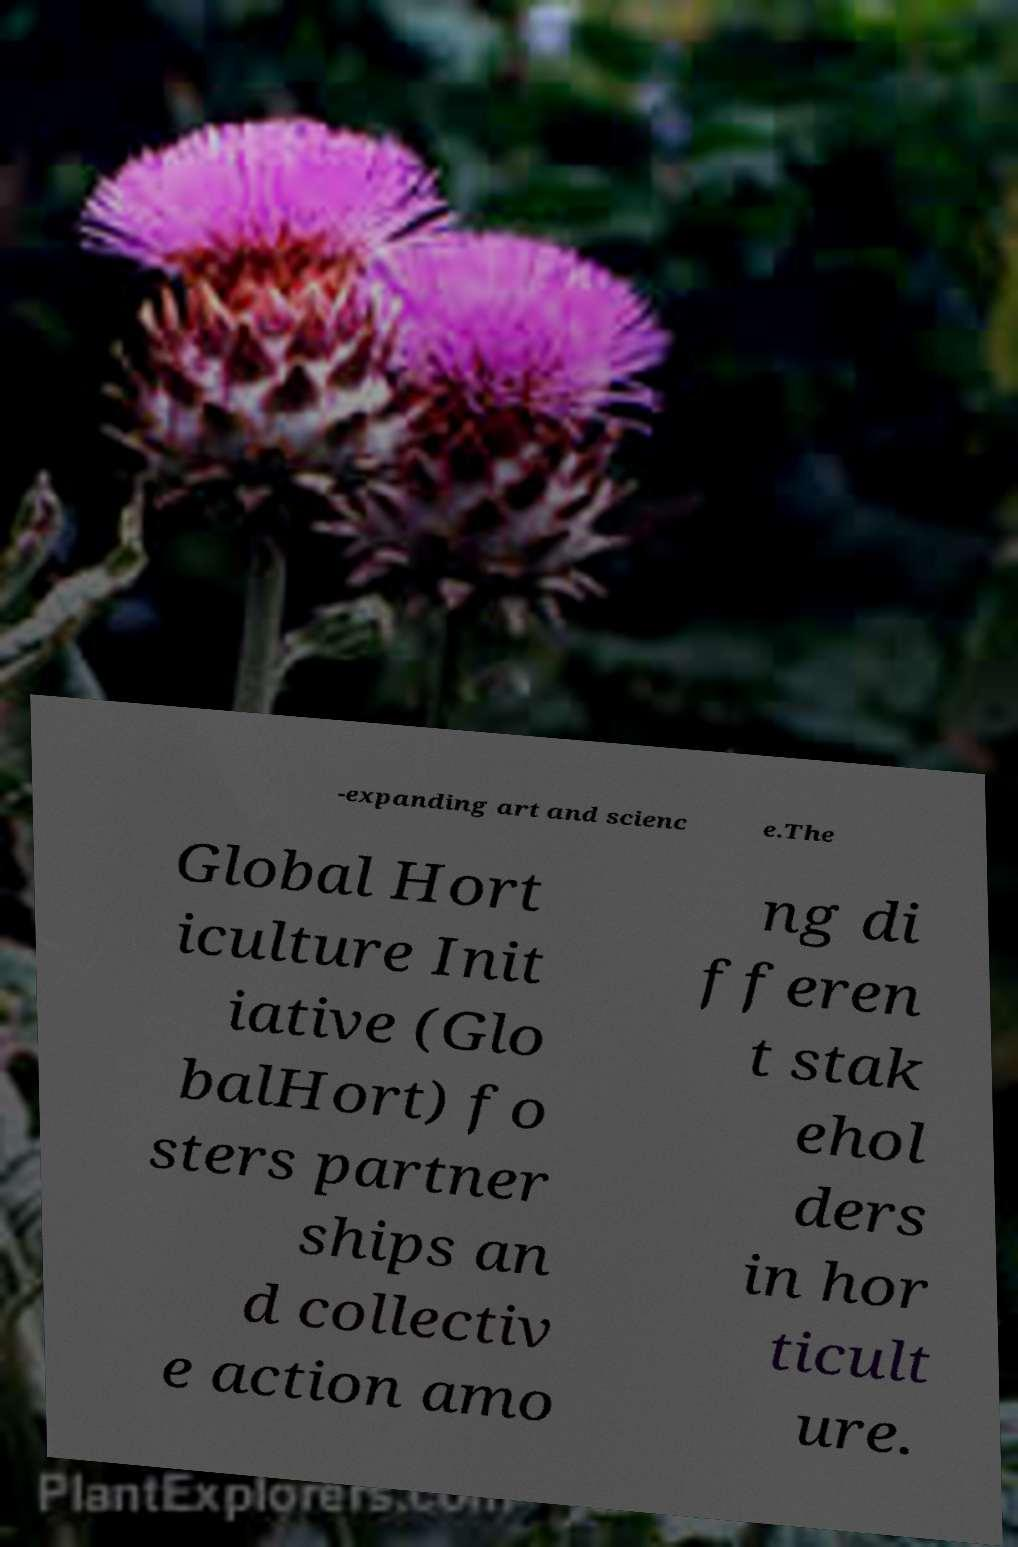Please read and relay the text visible in this image. What does it say? -expanding art and scienc e.The Global Hort iculture Init iative (Glo balHort) fo sters partner ships an d collectiv e action amo ng di fferen t stak ehol ders in hor ticult ure. 